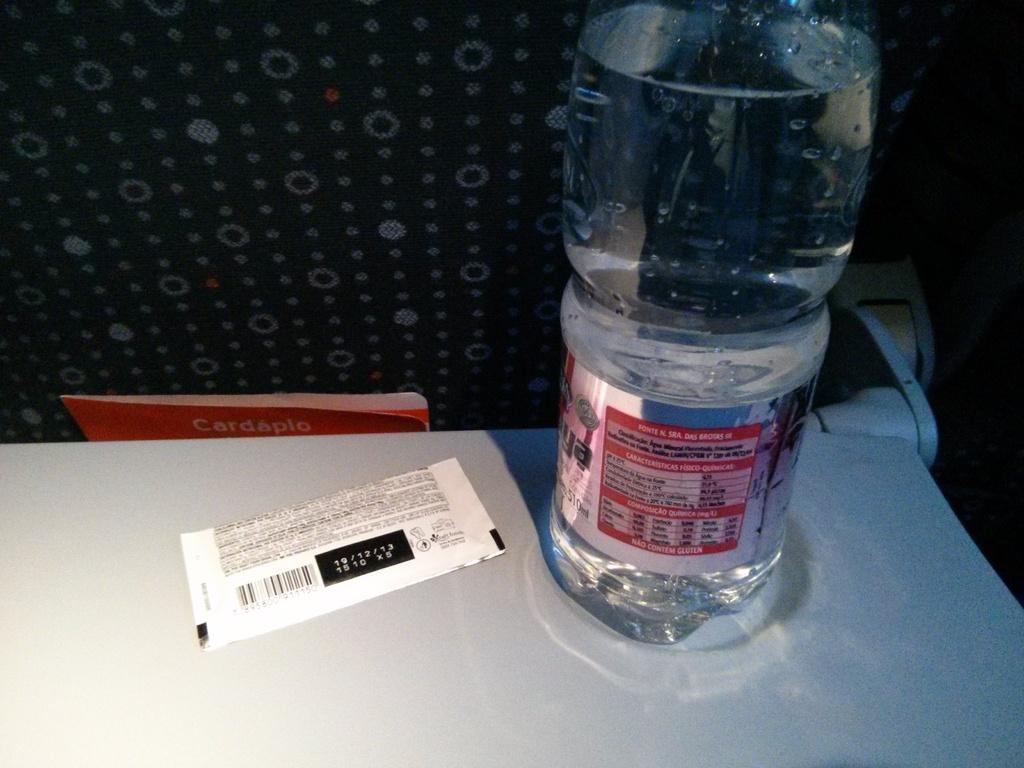When does that pack expire?
Make the answer very short. 10/12/13. 